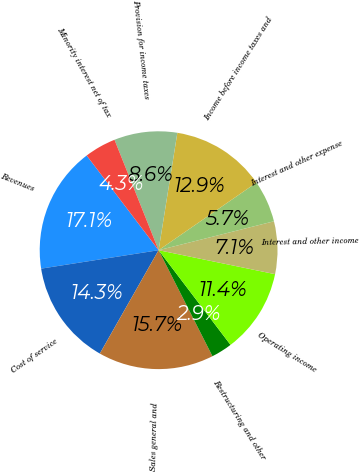Convert chart. <chart><loc_0><loc_0><loc_500><loc_500><pie_chart><fcel>Revenues<fcel>Cost of service<fcel>Sales general and<fcel>Restructuring and other<fcel>Operating income<fcel>Interest and other income<fcel>Interest and other expense<fcel>Income before income taxes and<fcel>Provision for income taxes<fcel>Minority interest net of tax<nl><fcel>17.14%<fcel>14.29%<fcel>15.71%<fcel>2.86%<fcel>11.43%<fcel>7.14%<fcel>5.71%<fcel>12.86%<fcel>8.57%<fcel>4.29%<nl></chart> 